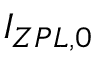Convert formula to latex. <formula><loc_0><loc_0><loc_500><loc_500>I _ { Z P L , 0 }</formula> 